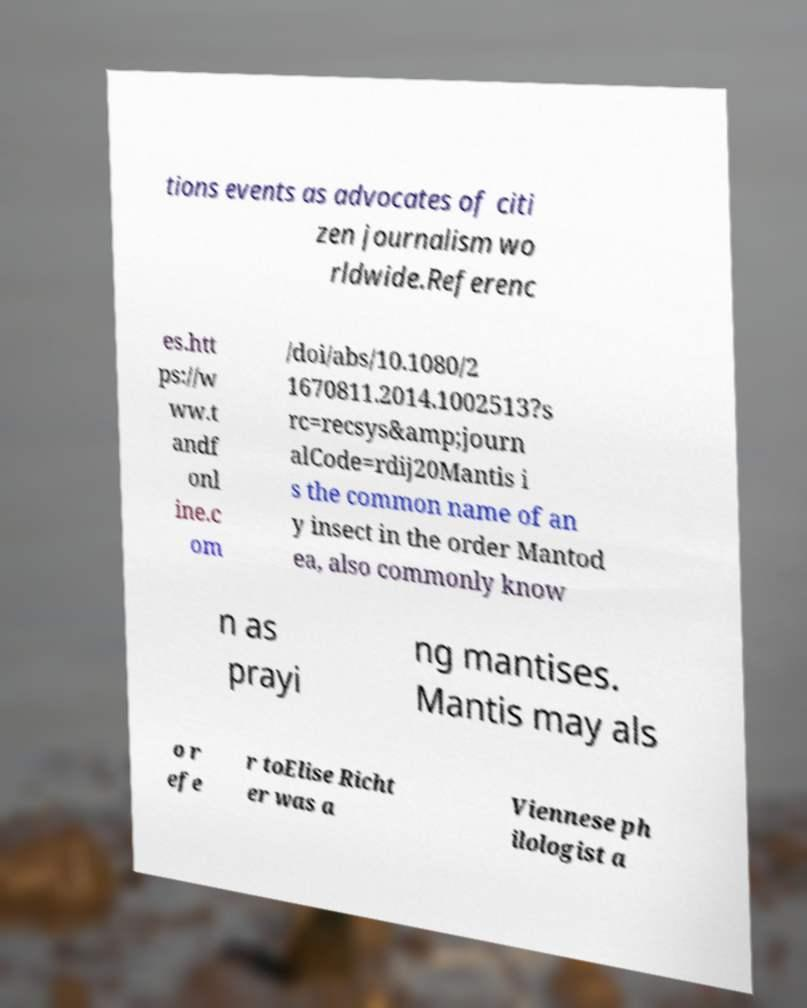Can you read and provide the text displayed in the image?This photo seems to have some interesting text. Can you extract and type it out for me? tions events as advocates of citi zen journalism wo rldwide.Referenc es.htt ps://w ww.t andf onl ine.c om /doi/abs/10.1080/2 1670811.2014.1002513?s rc=recsys&amp;journ alCode=rdij20Mantis i s the common name of an y insect in the order Mantod ea, also commonly know n as prayi ng mantises. Mantis may als o r efe r toElise Richt er was a Viennese ph ilologist a 